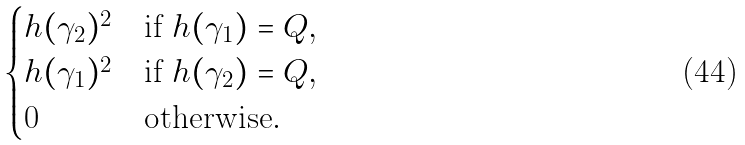Convert formula to latex. <formula><loc_0><loc_0><loc_500><loc_500>\begin{cases} h ( \gamma _ { 2 } ) ^ { 2 } & \text {if $h(\gamma_{1}) = Q$} , \\ h ( \gamma _ { 1 } ) ^ { 2 } & \text {if $h(\gamma_{2}) = Q$} , \\ 0 & \text {otherwise} . \end{cases}</formula> 